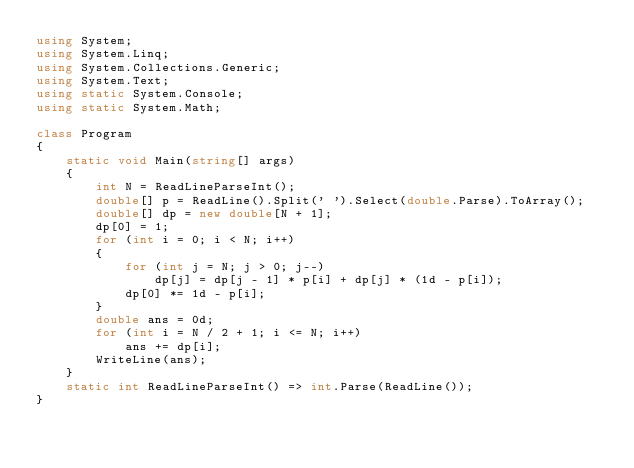Convert code to text. <code><loc_0><loc_0><loc_500><loc_500><_C#_>using System;
using System.Linq;
using System.Collections.Generic;
using System.Text;
using static System.Console;
using static System.Math;

class Program
{
    static void Main(string[] args)
    {
        int N = ReadLineParseInt();
        double[] p = ReadLine().Split(' ').Select(double.Parse).ToArray();
        double[] dp = new double[N + 1];
        dp[0] = 1;
        for (int i = 0; i < N; i++)
        {
            for (int j = N; j > 0; j--)
                dp[j] = dp[j - 1] * p[i] + dp[j] * (1d - p[i]);
            dp[0] *= 1d - p[i];
        }
        double ans = 0d;
        for (int i = N / 2 + 1; i <= N; i++)
            ans += dp[i];
        WriteLine(ans);
    }
    static int ReadLineParseInt() => int.Parse(ReadLine());
}</code> 